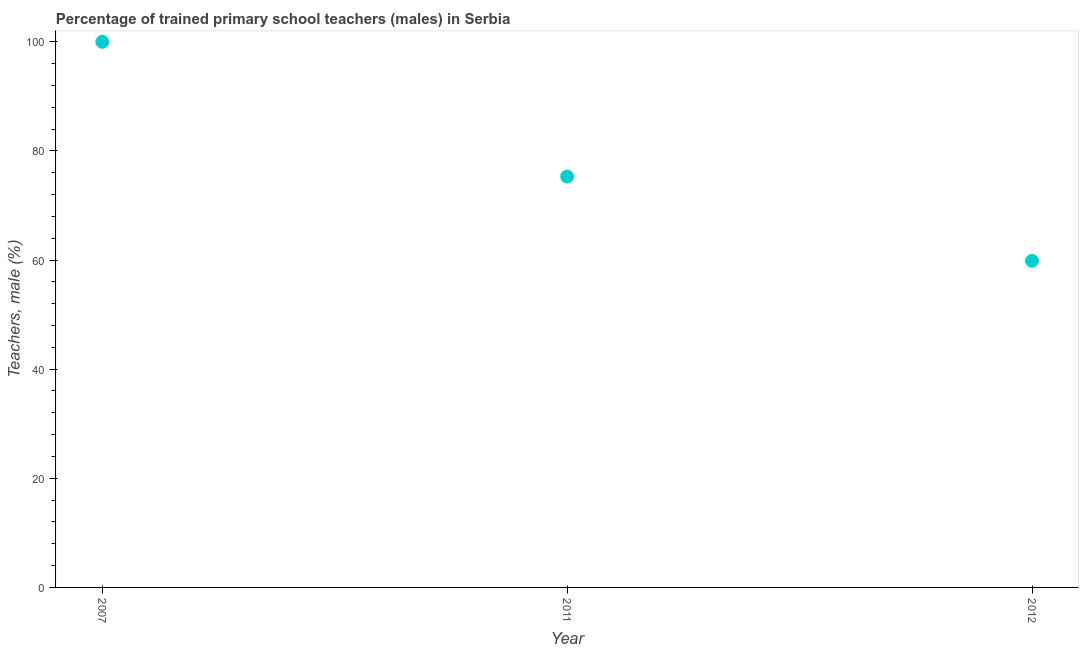What is the percentage of trained male teachers in 2011?
Your answer should be compact. 75.3. Across all years, what is the maximum percentage of trained male teachers?
Keep it short and to the point. 100. Across all years, what is the minimum percentage of trained male teachers?
Provide a succinct answer. 59.85. In which year was the percentage of trained male teachers minimum?
Provide a succinct answer. 2012. What is the sum of the percentage of trained male teachers?
Offer a terse response. 235.14. What is the difference between the percentage of trained male teachers in 2011 and 2012?
Provide a short and direct response. 15.45. What is the average percentage of trained male teachers per year?
Your answer should be very brief. 78.38. What is the median percentage of trained male teachers?
Offer a terse response. 75.3. Do a majority of the years between 2011 and 2007 (inclusive) have percentage of trained male teachers greater than 40 %?
Give a very brief answer. No. What is the ratio of the percentage of trained male teachers in 2007 to that in 2011?
Make the answer very short. 1.33. Is the percentage of trained male teachers in 2011 less than that in 2012?
Ensure brevity in your answer.  No. What is the difference between the highest and the second highest percentage of trained male teachers?
Offer a very short reply. 24.7. Is the sum of the percentage of trained male teachers in 2011 and 2012 greater than the maximum percentage of trained male teachers across all years?
Ensure brevity in your answer.  Yes. What is the difference between the highest and the lowest percentage of trained male teachers?
Your answer should be very brief. 40.15. Does the percentage of trained male teachers monotonically increase over the years?
Offer a very short reply. No. How many dotlines are there?
Keep it short and to the point. 1. How many years are there in the graph?
Offer a terse response. 3. What is the difference between two consecutive major ticks on the Y-axis?
Your answer should be very brief. 20. What is the title of the graph?
Give a very brief answer. Percentage of trained primary school teachers (males) in Serbia. What is the label or title of the Y-axis?
Your answer should be compact. Teachers, male (%). What is the Teachers, male (%) in 2011?
Your answer should be compact. 75.3. What is the Teachers, male (%) in 2012?
Keep it short and to the point. 59.85. What is the difference between the Teachers, male (%) in 2007 and 2011?
Your answer should be compact. 24.7. What is the difference between the Teachers, male (%) in 2007 and 2012?
Provide a short and direct response. 40.15. What is the difference between the Teachers, male (%) in 2011 and 2012?
Provide a short and direct response. 15.45. What is the ratio of the Teachers, male (%) in 2007 to that in 2011?
Your answer should be very brief. 1.33. What is the ratio of the Teachers, male (%) in 2007 to that in 2012?
Your response must be concise. 1.67. What is the ratio of the Teachers, male (%) in 2011 to that in 2012?
Give a very brief answer. 1.26. 